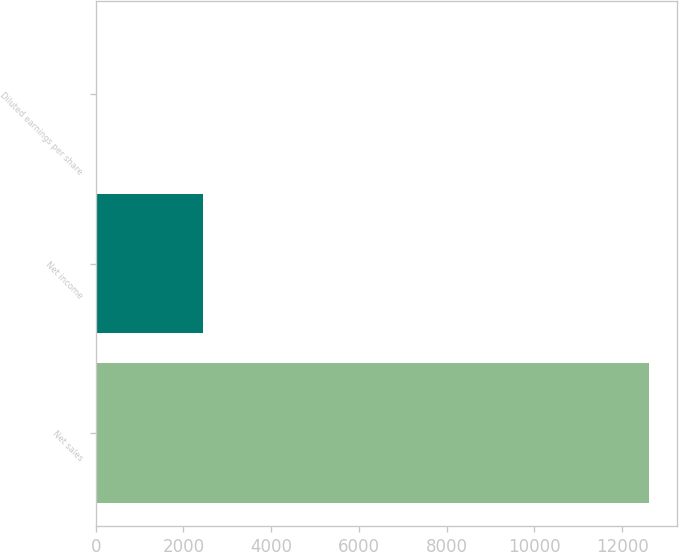Convert chart. <chart><loc_0><loc_0><loc_500><loc_500><bar_chart><fcel>Net sales<fcel>Net income<fcel>Diluted earnings per share<nl><fcel>12613<fcel>2448<fcel>5.96<nl></chart> 